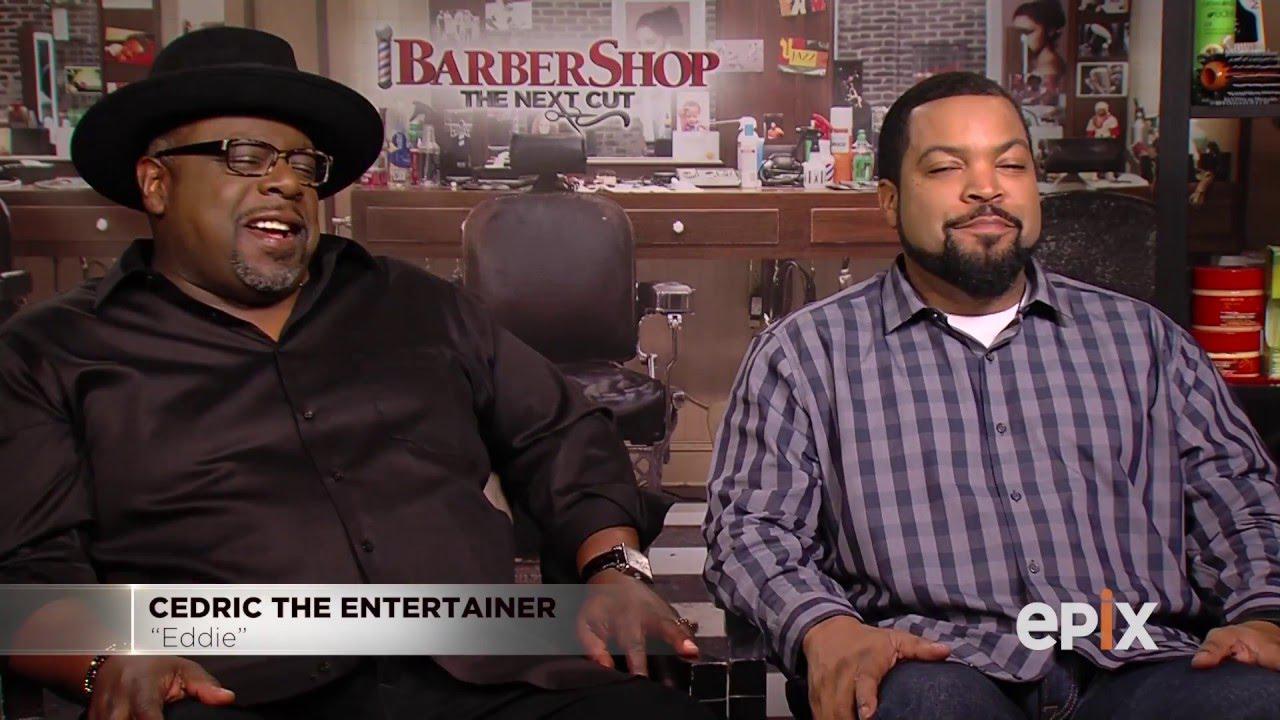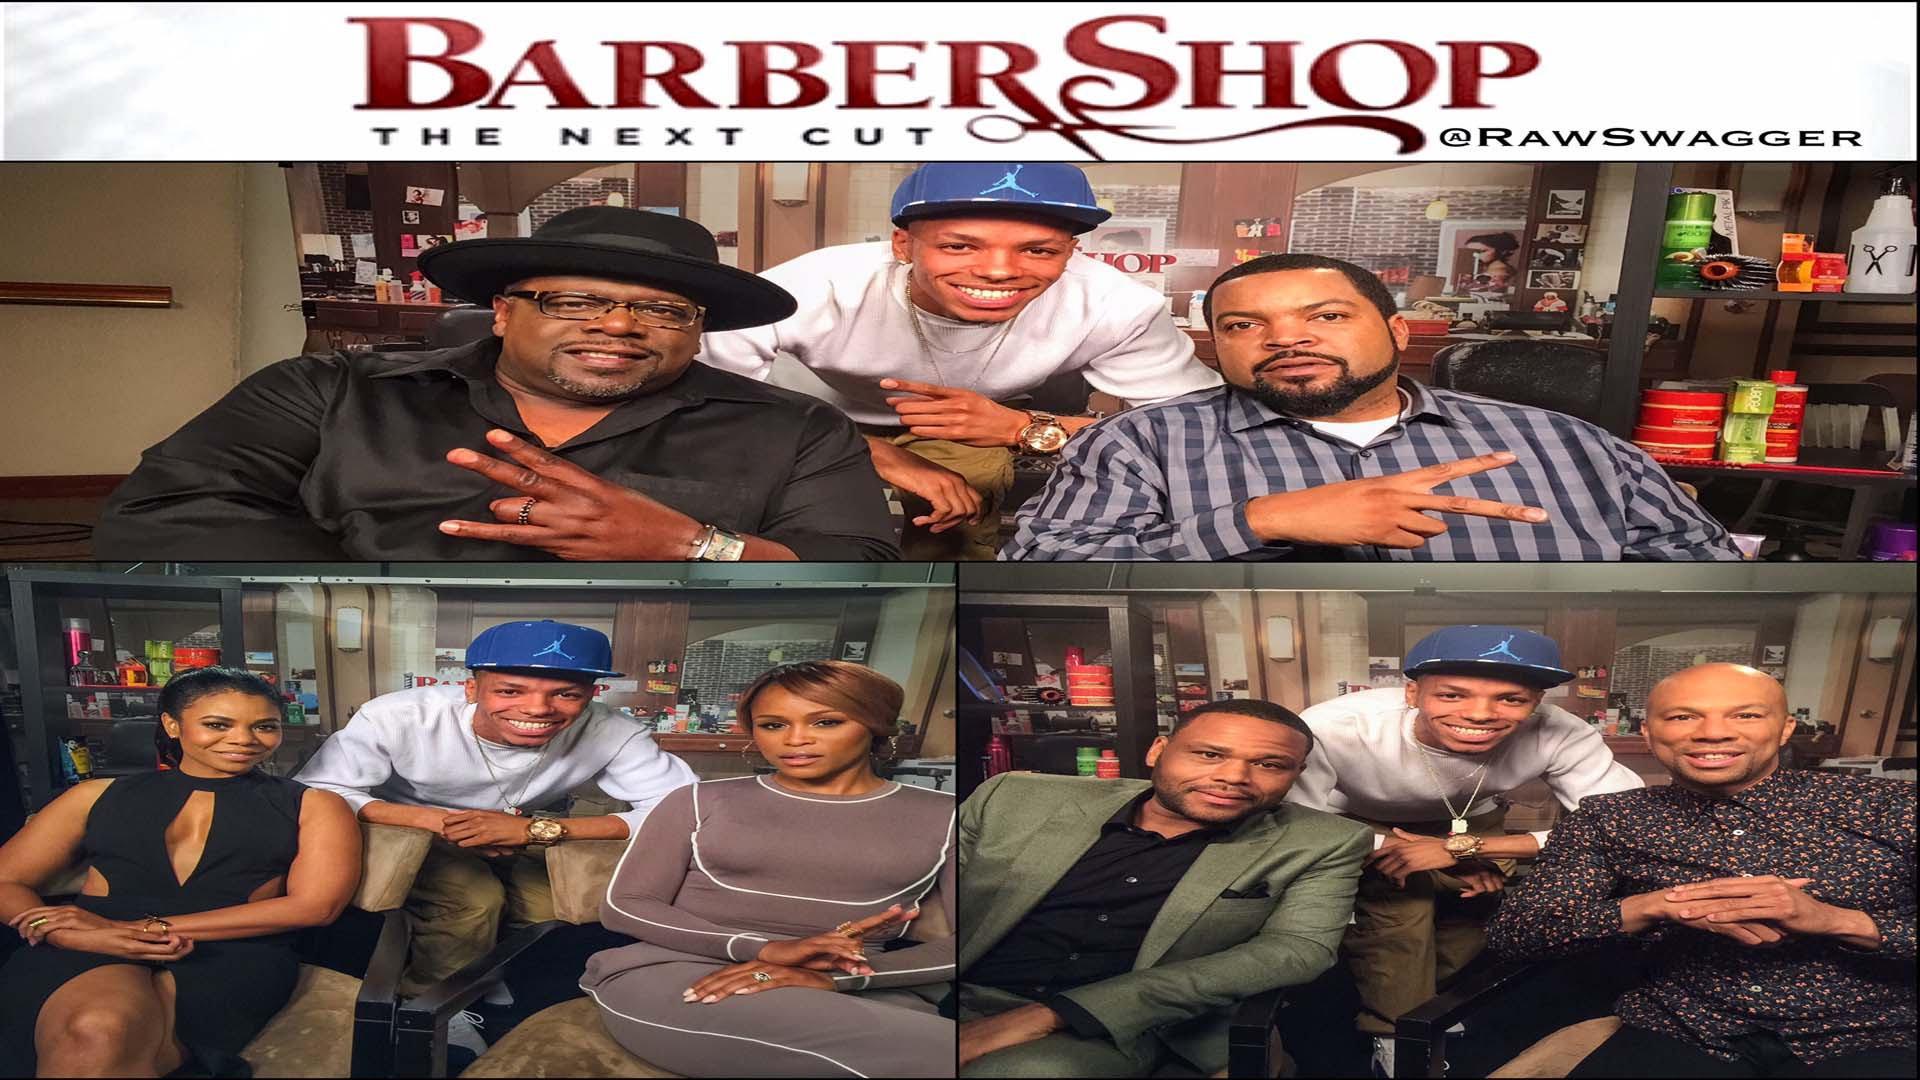The first image is the image on the left, the second image is the image on the right. Given the left and right images, does the statement "Caucasian males are getting their hair cut" hold true? Answer yes or no. No. The first image is the image on the left, the second image is the image on the right. For the images shown, is this caption "At least one image shows a male barber standing to work on a customer's hair." true? Answer yes or no. No. 